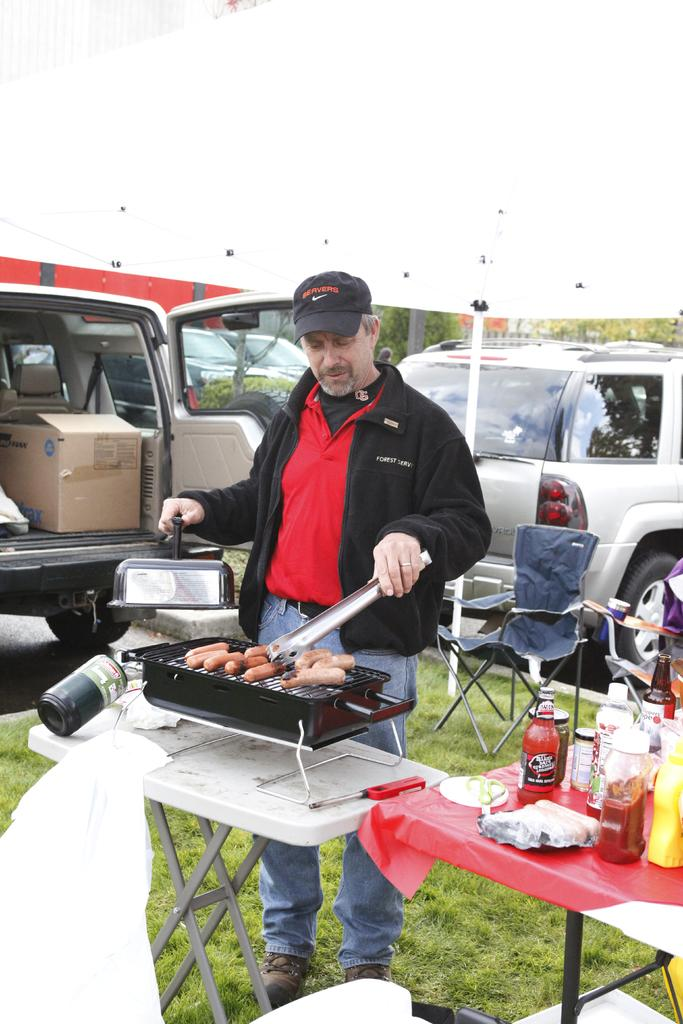What is the person in the image doing? The person is cooking in the image. What type of food is the person cooking? The person is cooking sausages. How is the cooking being done? The cooking is being done on a grill. What can be seen in the background of the image? There are vehicles and trees in the background of the image. What substance is the wren using to fuel its journey in the image? There is no wren present in the image, and therefore no such substance or journey can be observed. 